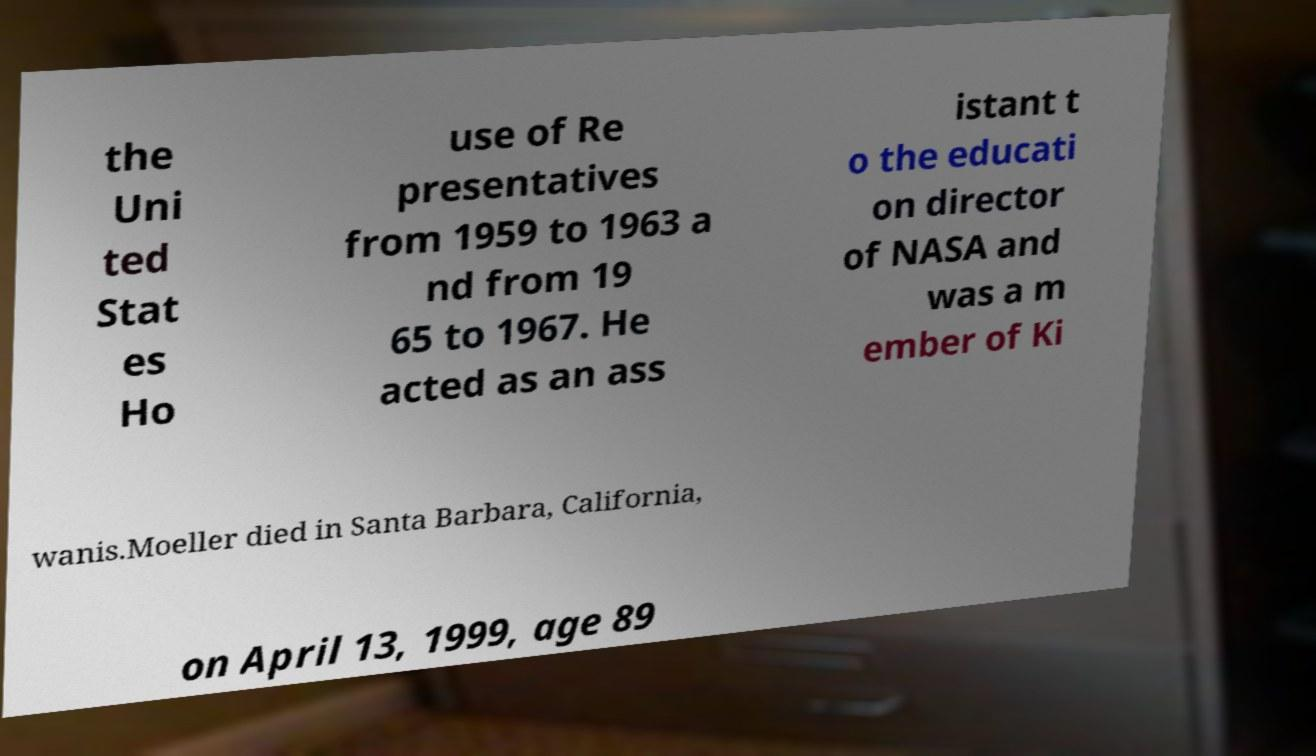I need the written content from this picture converted into text. Can you do that? the Uni ted Stat es Ho use of Re presentatives from 1959 to 1963 a nd from 19 65 to 1967. He acted as an ass istant t o the educati on director of NASA and was a m ember of Ki wanis.Moeller died in Santa Barbara, California, on April 13, 1999, age 89 